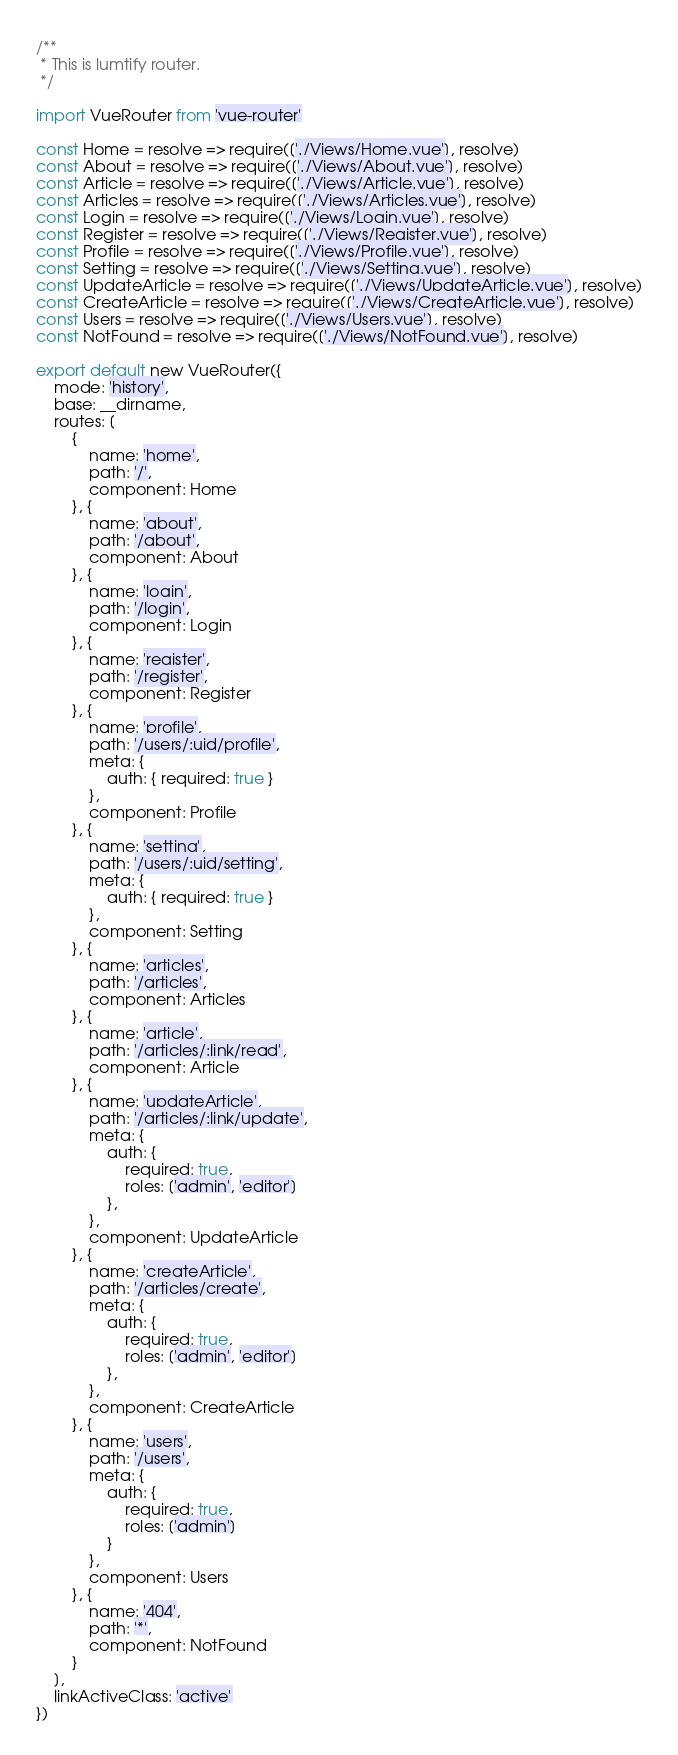<code> <loc_0><loc_0><loc_500><loc_500><_JavaScript_>/**
 * This is lumtify router.
 */

import VueRouter from 'vue-router'

const Home = resolve => require(['./Views/Home.vue'], resolve)
const About = resolve => require(['./Views/About.vue'], resolve)
const Article = resolve => require(['./Views/Article.vue'], resolve)
const Articles = resolve => require(['./Views/Articles.vue'], resolve)
const Login = resolve => require(['./Views/Login.vue'], resolve)
const Register = resolve => require(['./Views/Register.vue'], resolve)
const Profile = resolve => require(['./Views/Profile.vue'], resolve)
const Setting = resolve => require(['./Views/Setting.vue'], resolve)
const UpdateArticle = resolve => require(['./Views/UpdateArticle.vue'], resolve)
const CreateArticle = resolve => require(['./Views/CreateArticle.vue'], resolve)
const Users = resolve => require(['./Views/Users.vue'], resolve)
const NotFound = resolve => require(['./Views/NotFound.vue'], resolve)

export default new VueRouter({
    mode: 'history',
    base: __dirname,
    routes: [
        { 
            name: 'home', 
            path: '/', 
            component: Home 
        }, { 
            name: 'about', 
            path: '/about', 
            component: About 
        }, { 
            name: 'login', 
            path: '/login',
            component: Login 
        }, { 
            name: 'register', 
            path: '/register',
            component: Register 
        }, { 
            name: 'profile', 
            path: '/users/:uid/profile', 
            meta: { 
                auth: { required: true }
            }, 
            component: Profile 
        }, { 
            name: 'setting', 
            path: '/users/:uid/setting', 
            meta: { 
                auth: { required: true } 
            }, 
            component: Setting 
        }, { 
            name: 'articles', 
            path: '/articles', 
            component: Articles 
        }, { 
            name: 'article', 
            path: '/articles/:link/read', 
            component: Article 
        }, { 
            name: 'updateArticle', 
            path: '/articles/:link/update', 
            meta: { 
                auth: { 
                    required: true,
                    roles: ['admin', 'editor']
                },
            }, 
            component: UpdateArticle 
        }, { 
            name: 'createArticle', 
            path: '/articles/create', 
            meta: { 
                auth: { 
                    required: true,
                    roles: ['admin', 'editor'] 
                },
            }, 
            component: CreateArticle 
        }, { 
            name: 'users', 
            path: '/users',
            meta: {
                auth: {
                    required: true,
                    roles: ['admin']
                }
            },
            component: Users 
        }, {
            name: '404',
            path: '*',
            component: NotFound
        }
    ],
    linkActiveClass: 'active'
})
</code> 